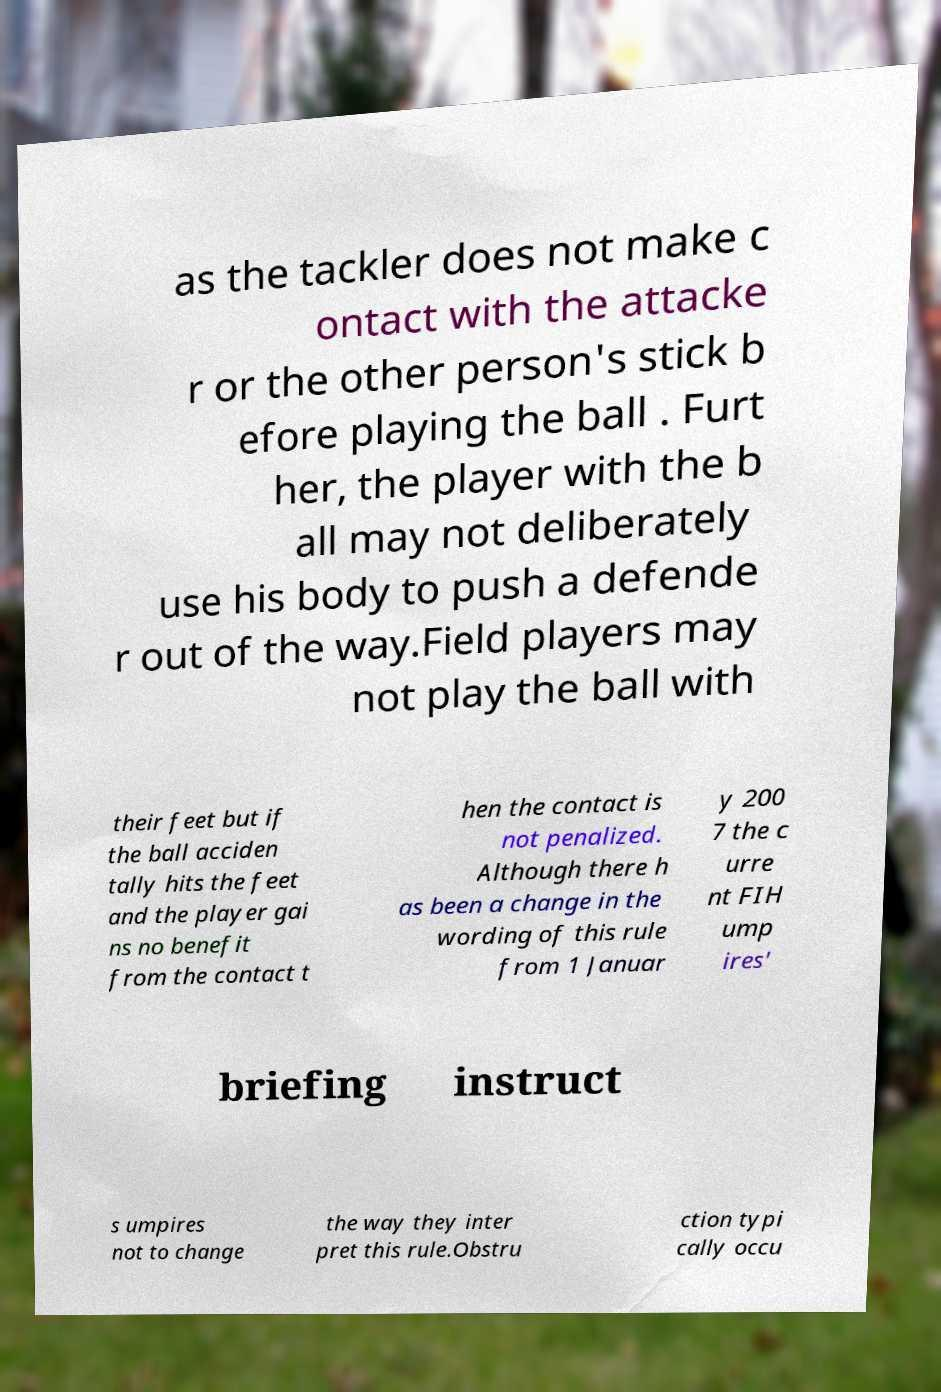Please identify and transcribe the text found in this image. as the tackler does not make c ontact with the attacke r or the other person's stick b efore playing the ball . Furt her, the player with the b all may not deliberately use his body to push a defende r out of the way.Field players may not play the ball with their feet but if the ball acciden tally hits the feet and the player gai ns no benefit from the contact t hen the contact is not penalized. Although there h as been a change in the wording of this rule from 1 Januar y 200 7 the c urre nt FIH ump ires' briefing instruct s umpires not to change the way they inter pret this rule.Obstru ction typi cally occu 